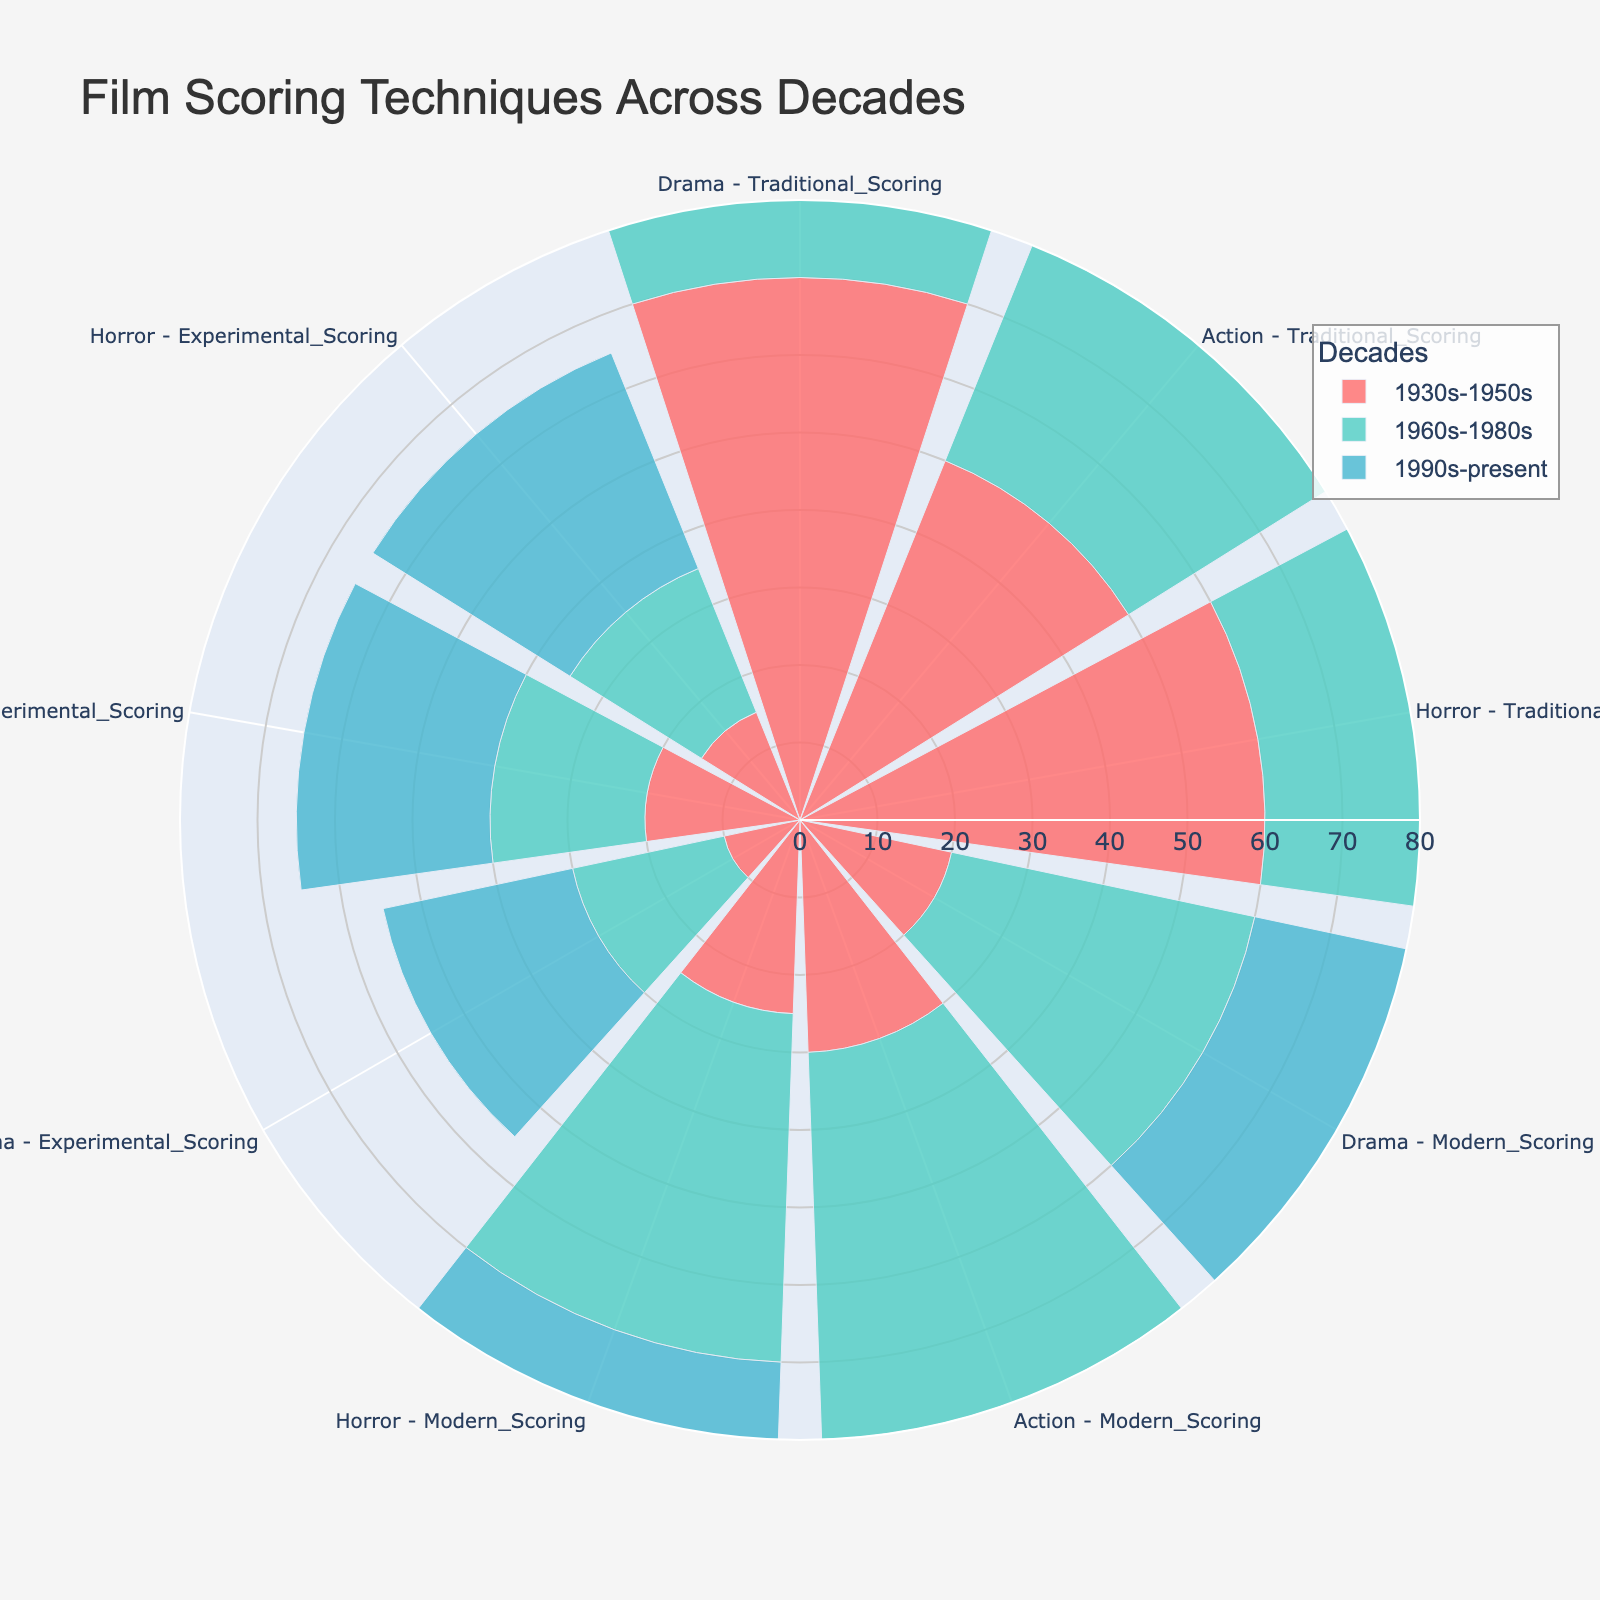What is the title of the figure? The title is typically located at the top of the figure and provides a summary of what the chart represents. Here, the title reads "Film Scoring Techniques Across Decades".
Answer: Film Scoring Techniques Across Decades Which scoring type has the highest representation in the 1990s-present for the Action genre? Look at the segment corresponding to the Action genre within the 1990s-present group and compare the heights of the segments for Traditional Scoring, Modern Scoring, and Experimental Scoring. The Modern Scoring type has the highest percentage.
Answer: Modern Scoring How does the range of Traditional Scoring percentages compare between the three decades? Examine the radial axis values for Traditional Scoring across the three decades. Traditional Scoring in the 1930s-1950s ranges between 50-70%, in the 1960s-1980s it ranges between 30-40%, and in the 1990s-present it ranges between 15-20%. Thus, the range decreases over time.
Answer: The range decreases over time Combine the percentages of Modern Scoring and Experimental Scoring for Drama in the 1960s-1980s. What is the total? Locate the segments for Modern Scoring and Experimental Scoring within the Drama genre for the 1960s-1980s and add the values together. Modern Scoring is 40% and Experimental Scoring is 20%, resulting in a total of 60%.
Answer: 60% Which decade shows the most balanced distribution among the three scoring techniques for Horror? Look at the Horror segment for each decade and compare the percentages of Traditional, Modern, and Experimental Scoring. The 1960s-1980s show a more balanced distribution with percentages of 35%, 45%, and 20% respectively.
Answer: 1960s-1980s Which genre has the highest representation of Experimental Scoring in the 1990s-present? Compare the percentages of Experimental Scoring across all genres in the 1990s-present. The Horror genre has the highest representation at 30%.
Answer: Horror What is the average percentage of Traditional Scoring across all genres for the 1930s-1950s? Add up the percentages of Traditional Scoring for Drama, Action, and Horror in the 1930s-1950s and divide by 3. The percentages are 70%, 50%, and 60%, summing to 180%. Dividing by 3 gives an average of 60%.
Answer: 60% Which scoring type sees the most significant increase in representation from the 1930s-1950s to the 1990s-present in the Drama genre? Compare the percentages of each scoring type in the Drama genre between the two decades. Traditional Scoring decreases from 70% to 20%, Modern Scoring increases from 20% to 55%, and Experimental Scoring increases from 10% to 25%. The most significant increase is in Modern Scoring.
Answer: Modern Scoring In which decade does Action have the lowest representation of Traditional Scoring? Identify the percentage values for Traditional Scoring in Action across the three decades. The lowest representation is in the 1990s-present at 15%.
Answer: 1990s-present 